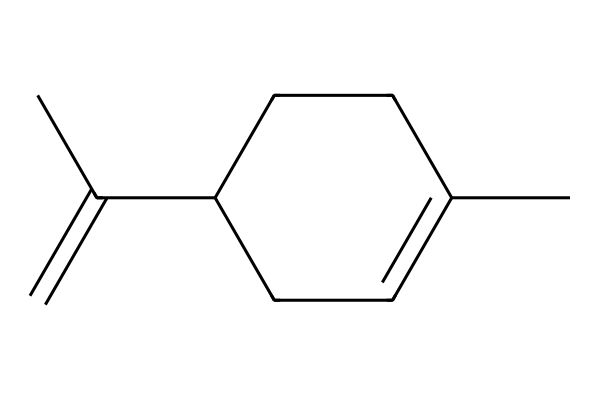What is the molecular formula of limonene? The SMILES representation provided can be analyzed to count the carbon (C) and hydrogen (H) atoms. From the structure, there are 10 carbon atoms and 16 hydrogen atoms.
Answer: C10H16 How many rings are present in this chemical structure? By examining the SMILES structure, there are no cycles indicated; it is a linear structure with one cyclohexane ring.
Answer: 1 Which functional group is present in limonene? The structure shows a double bond (C=C), indicating it is an alkene. Alkenes are characterized by having at least one carbon-carbon double bond.
Answer: alkene What is a characteristic aroma associated with limonene? Limonene is known for its citrusy aroma, which is typically reminiscent of lemon or orange. This aroma characteristic is due to its structural properties.
Answer: citrus How many geometric isomers can limonene have? Limonene can exist in multiple geometric isomer forms due to the presence of the double bond and the associated spatial arrangements. Specifically, it has two geometric isomers: cis and trans.
Answer: 2 What determines the different aromas of geometric isomers of limonene? The distinct spatial arrangement of the atoms in the isomers affects how they interact with olfactory receptors, leading to different smells being perceived from each isomer.
Answer: spatial arrangement Which geometric isomer of limonene is typically found in citrus oils? In citrus oils, the trans isomer of limonene is the most common and is primarily responsible for the characteristic lemon and orange scents.
Answer: trans isomer 